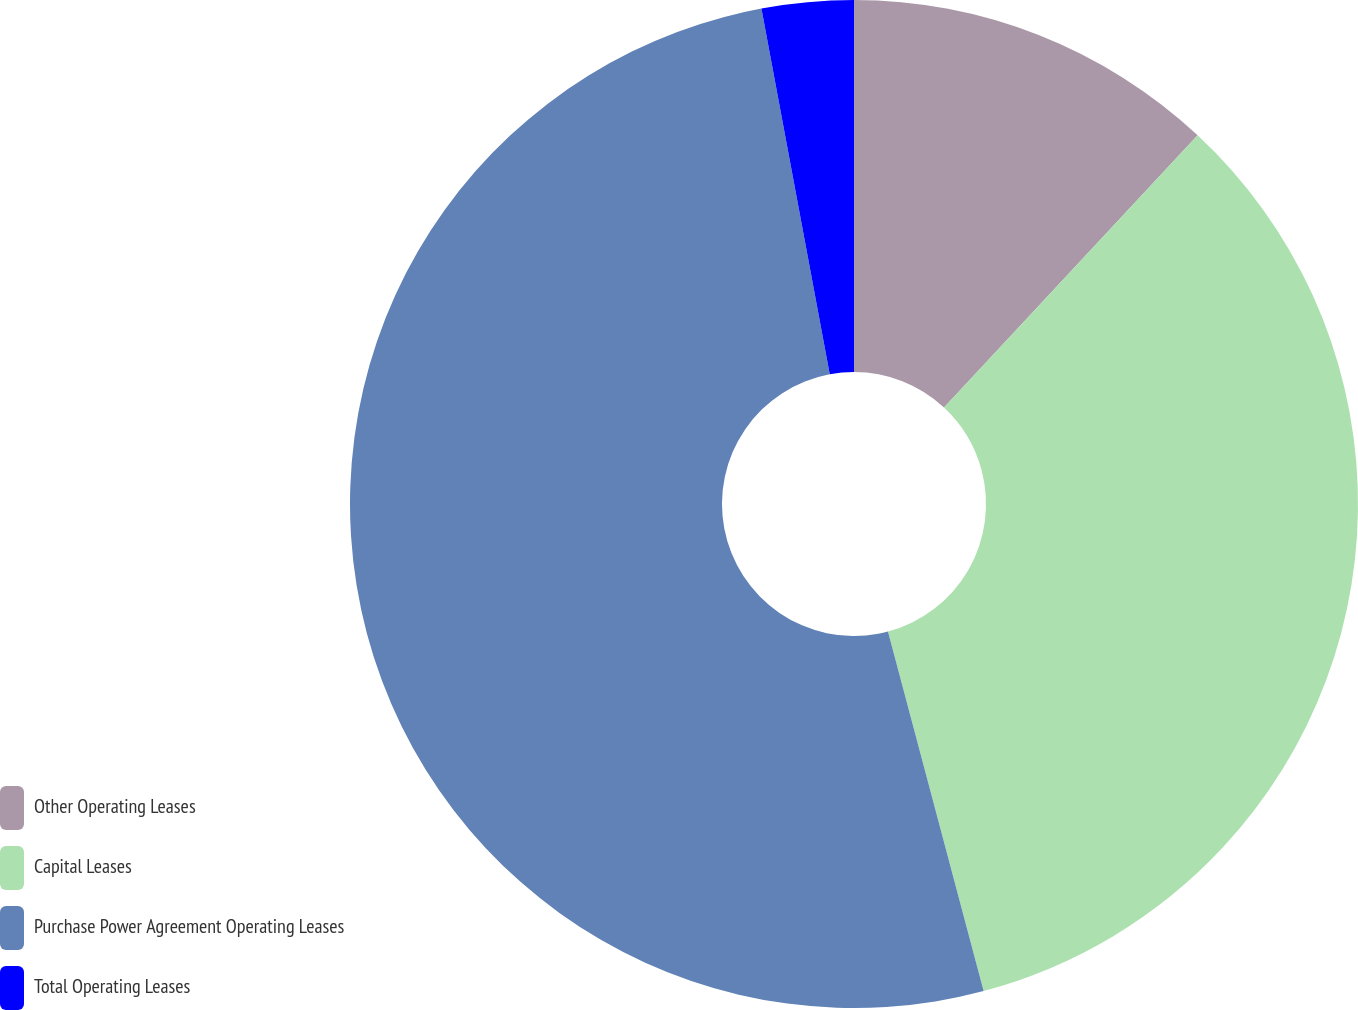Convert chart to OTSL. <chart><loc_0><loc_0><loc_500><loc_500><pie_chart><fcel>Other Operating Leases<fcel>Capital Leases<fcel>Purchase Power Agreement Operating Leases<fcel>Total Operating Leases<nl><fcel>11.94%<fcel>33.92%<fcel>51.2%<fcel>2.94%<nl></chart> 